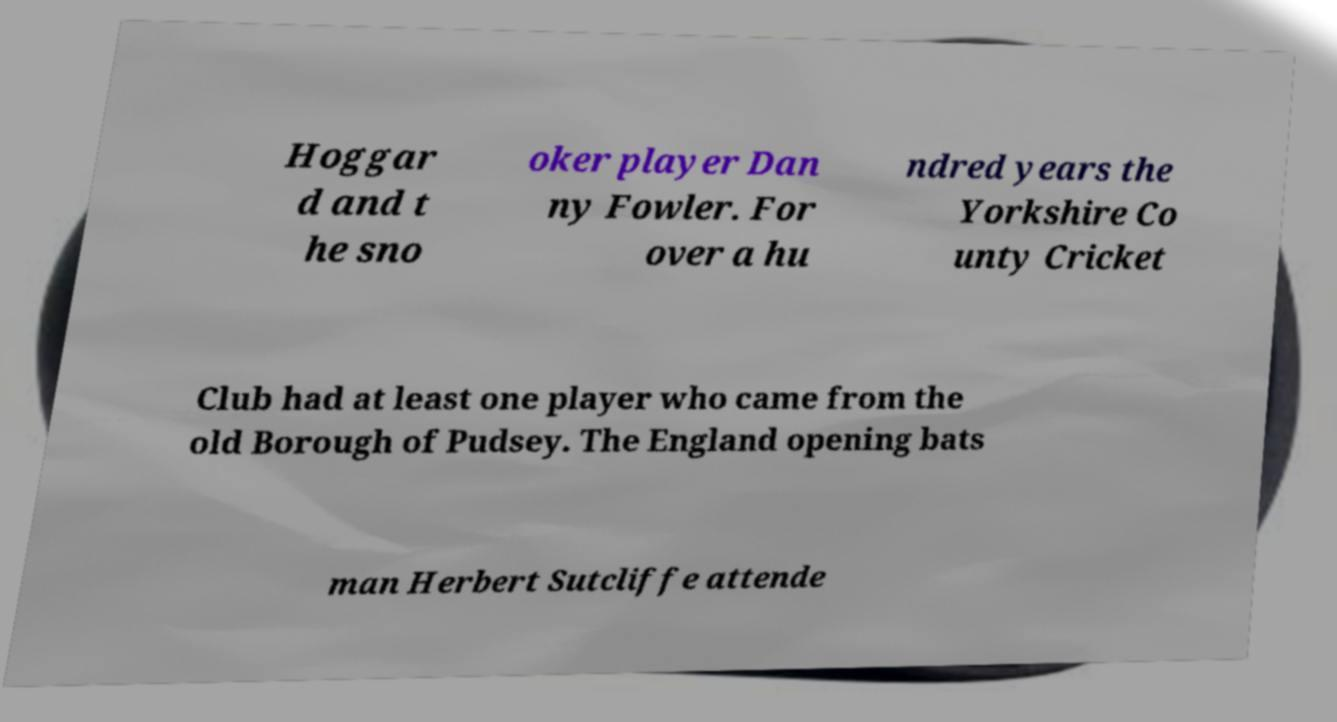There's text embedded in this image that I need extracted. Can you transcribe it verbatim? Hoggar d and t he sno oker player Dan ny Fowler. For over a hu ndred years the Yorkshire Co unty Cricket Club had at least one player who came from the old Borough of Pudsey. The England opening bats man Herbert Sutcliffe attende 